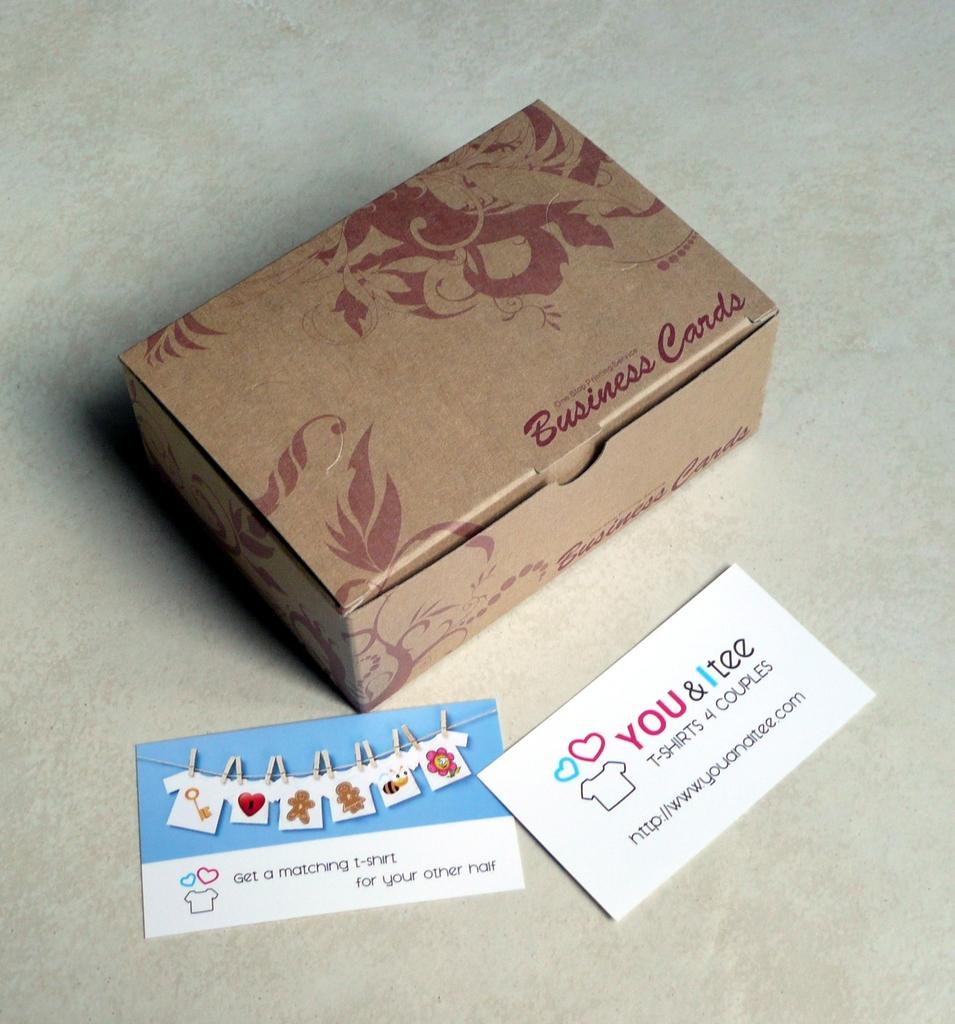What does the box say?
Your response must be concise. Business cards. Are these t-shirts for couples?
Make the answer very short. Yes. 